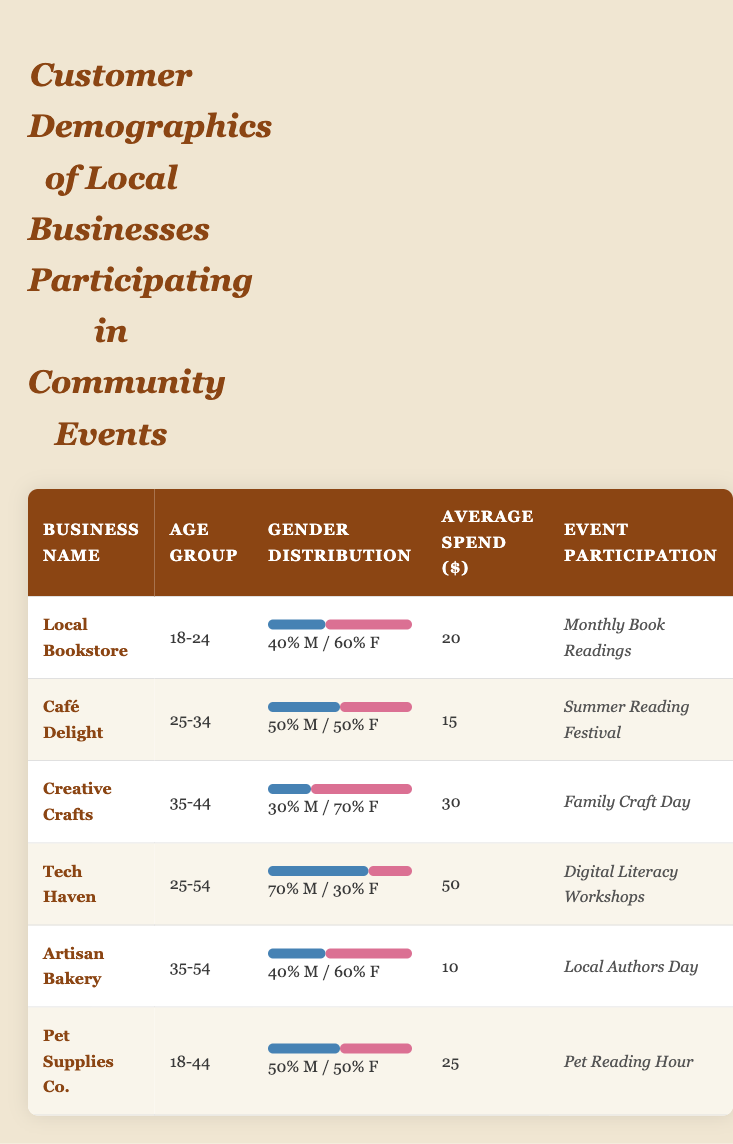What is the gender distribution of the Creative Crafts business? The gender distribution for Creative Crafts shows 30% male and 70% female based on the visual representation in the table.
Answer: 30% male and 70% female Which business has the highest average spend? By comparing the average spends in the table, Tech Haven has the highest average spend of $50.
Answer: Tech Haven with $50 Are there any businesses with the same gender distribution of 50% male and 50% female? Yes, both Café Delight and Pet Supplies Co. have a gender distribution of 50% male and 50% female according to the table.
Answer: Yes What is the average spend across all businesses? To find the average spend, sum the average spends of all businesses: (20 + 15 + 30 + 50 + 10 + 25) = 150. There are 6 businesses, so the average is 150/6 = 25.
Answer: $25 Which age group has the lowest average spend? By looking at the average spends in the table, Artisan Bakery with an average spend of $10 is the lowest, and it belongs to the age group of 35-54.
Answer: Age group 35-54 with $10 Does the Local Bookstore participate in the Summer Reading Festival? No, the Local Bookstore participates in Monthly Book Readings, not in the Summer Reading Festival according to the event participation column.
Answer: No Which businesses have age groups that overlap with 25-34? Café Delight (25-34) and Tech Haven (25-54) have overlapping age groups. The age range of 25-34 is inclusive in their respective age groups.
Answer: Café Delight and Tech Haven If you combine the male and female percentages for Tech Haven, what is the total? Adding the percentages, 70% male and 30% female equals 100%. Hence, combined they total 100%.
Answer: 100% Which event has the business with the second highest average spending? Tech Haven participates in Digital Literacy Workshops, which has the highest average spend of $50. Creative Crafts participates in the Family Craft Day and has the second highest average spend of $30.
Answer: Family Craft Day Is there a business that has a higher average spend than the Local Bookstore? Yes, both Tech Haven ($50) and Creative Crafts ($30) have higher average spends than the Local Bookstore ($20).
Answer: Yes 